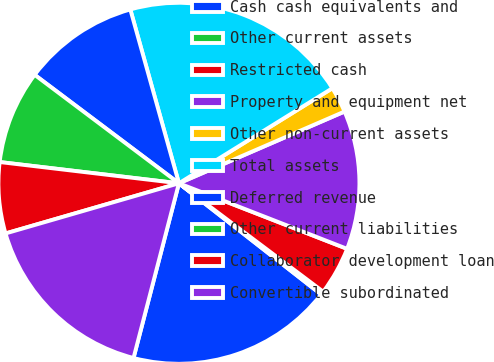Convert chart. <chart><loc_0><loc_0><loc_500><loc_500><pie_chart><fcel>Cash cash equivalents and<fcel>Other current assets<fcel>Restricted cash<fcel>Property and equipment net<fcel>Other non-current assets<fcel>Total assets<fcel>Deferred revenue<fcel>Other current liabilities<fcel>Collaborator development loan<fcel>Convertible subordinated<nl><fcel>18.49%<fcel>0.3%<fcel>4.34%<fcel>12.42%<fcel>2.32%<fcel>20.51%<fcel>10.4%<fcel>8.38%<fcel>6.36%<fcel>16.47%<nl></chart> 